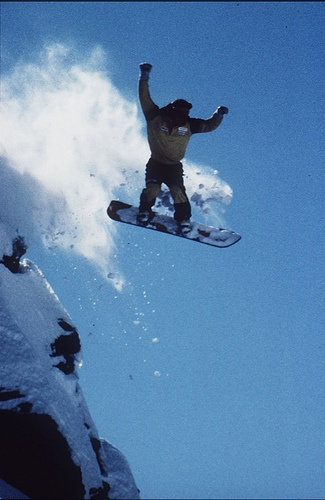Describe the objects in this image and their specific colors. I can see people in black, navy, and gray tones and snowboard in black, gray, darkblue, and navy tones in this image. 